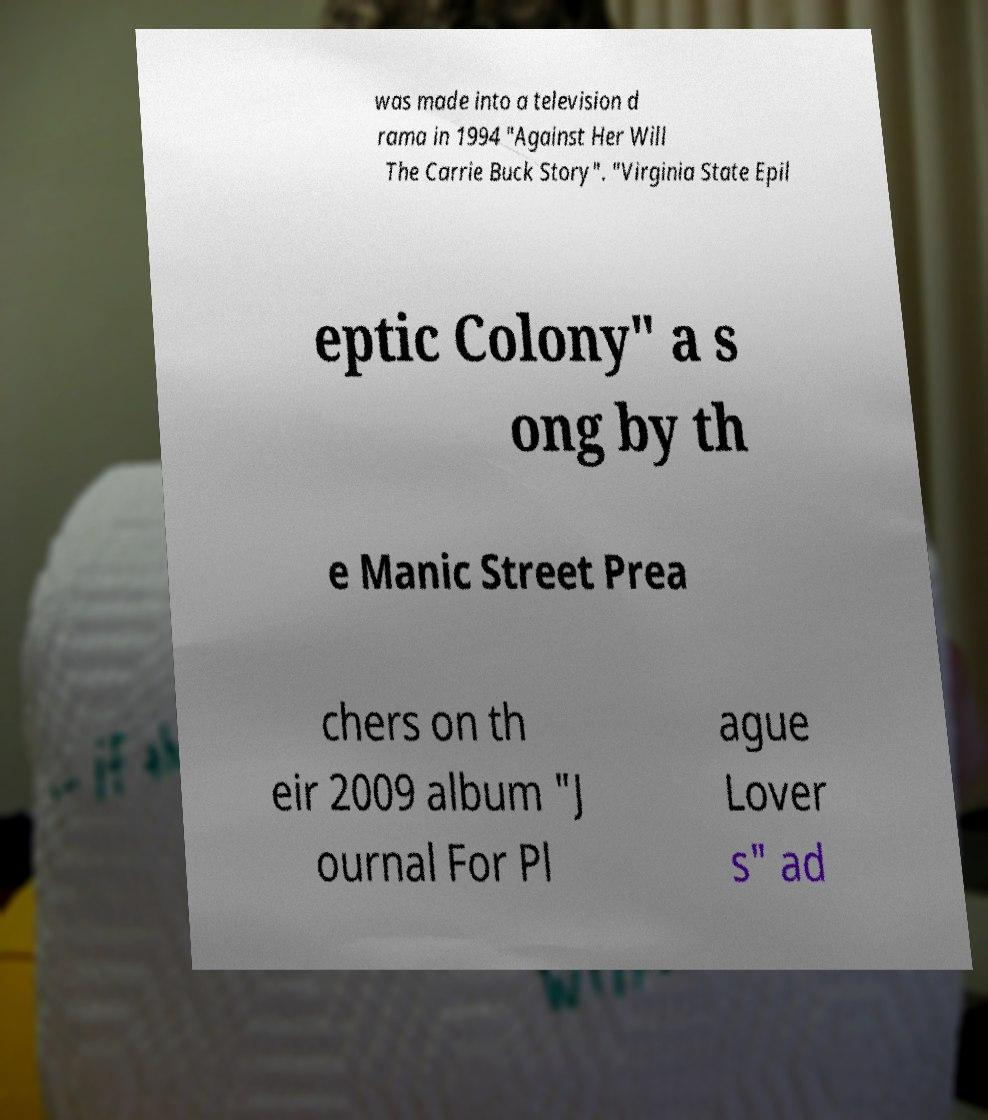There's text embedded in this image that I need extracted. Can you transcribe it verbatim? was made into a television d rama in 1994 "Against Her Will The Carrie Buck Story". "Virginia State Epil eptic Colony" a s ong by th e Manic Street Prea chers on th eir 2009 album "J ournal For Pl ague Lover s" ad 